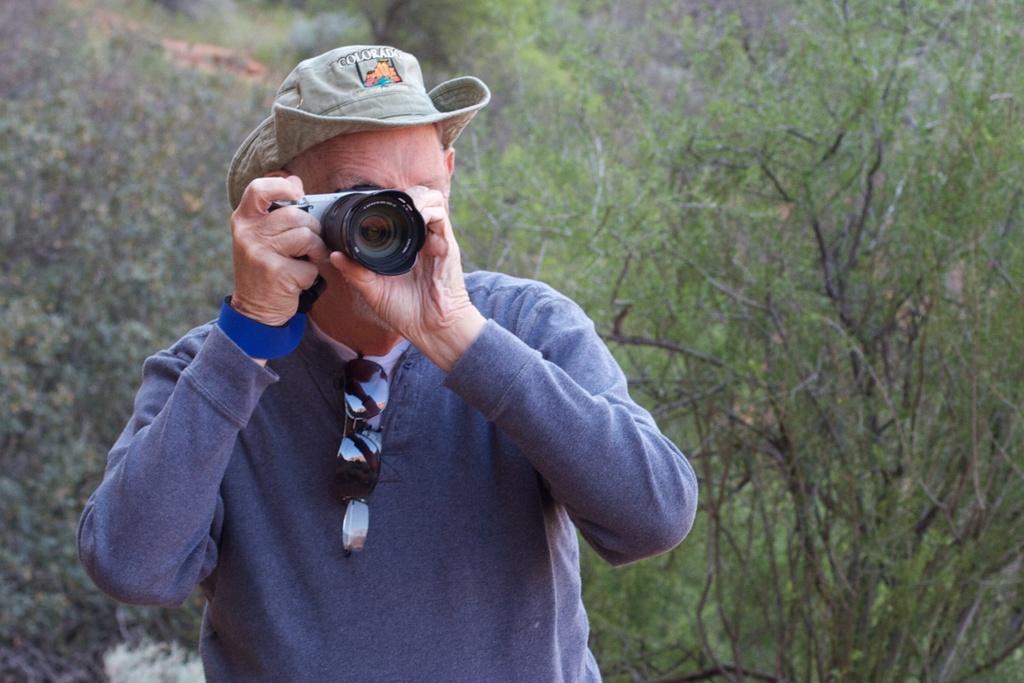Could you give a brief overview of what you see in this image? A person is wearing a blue jacket. A specks and a goggles is hanged on the jacket. He is having a hat also holding a camera and capturing image. In the background there are trees. 